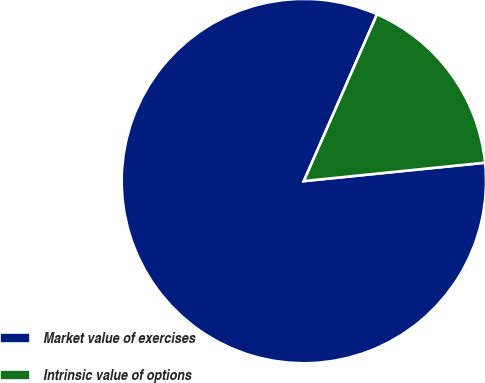Convert chart to OTSL. <chart><loc_0><loc_0><loc_500><loc_500><pie_chart><fcel>Market value of exercises<fcel>Intrinsic value of options<nl><fcel>83.19%<fcel>16.81%<nl></chart> 